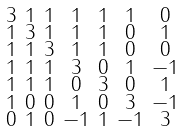<formula> <loc_0><loc_0><loc_500><loc_500>\begin{smallmatrix} 3 & 1 & 1 & 1 & 1 & 1 & 0 \\ 1 & 3 & 1 & 1 & 1 & 0 & 1 \\ 1 & 1 & 3 & 1 & 1 & 0 & 0 \\ 1 & 1 & 1 & 3 & 0 & 1 & - 1 \\ 1 & 1 & 1 & 0 & 3 & 0 & 1 \\ 1 & 0 & 0 & 1 & 0 & 3 & - 1 \\ 0 & 1 & 0 & - 1 & 1 & - 1 & 3 \end{smallmatrix}</formula> 